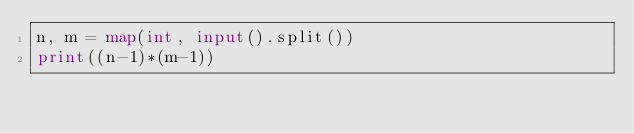<code> <loc_0><loc_0><loc_500><loc_500><_Python_>n, m = map(int, input().split())
print((n-1)*(m-1))</code> 